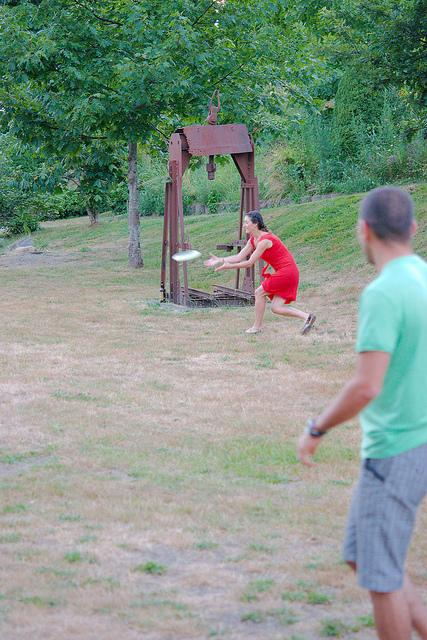What is the woman in red reaching towards? Please explain your reasoning. frisbee. It is a round flying disk that is typical of this type of object.  this object is used in a game where you throw it back and forth. 